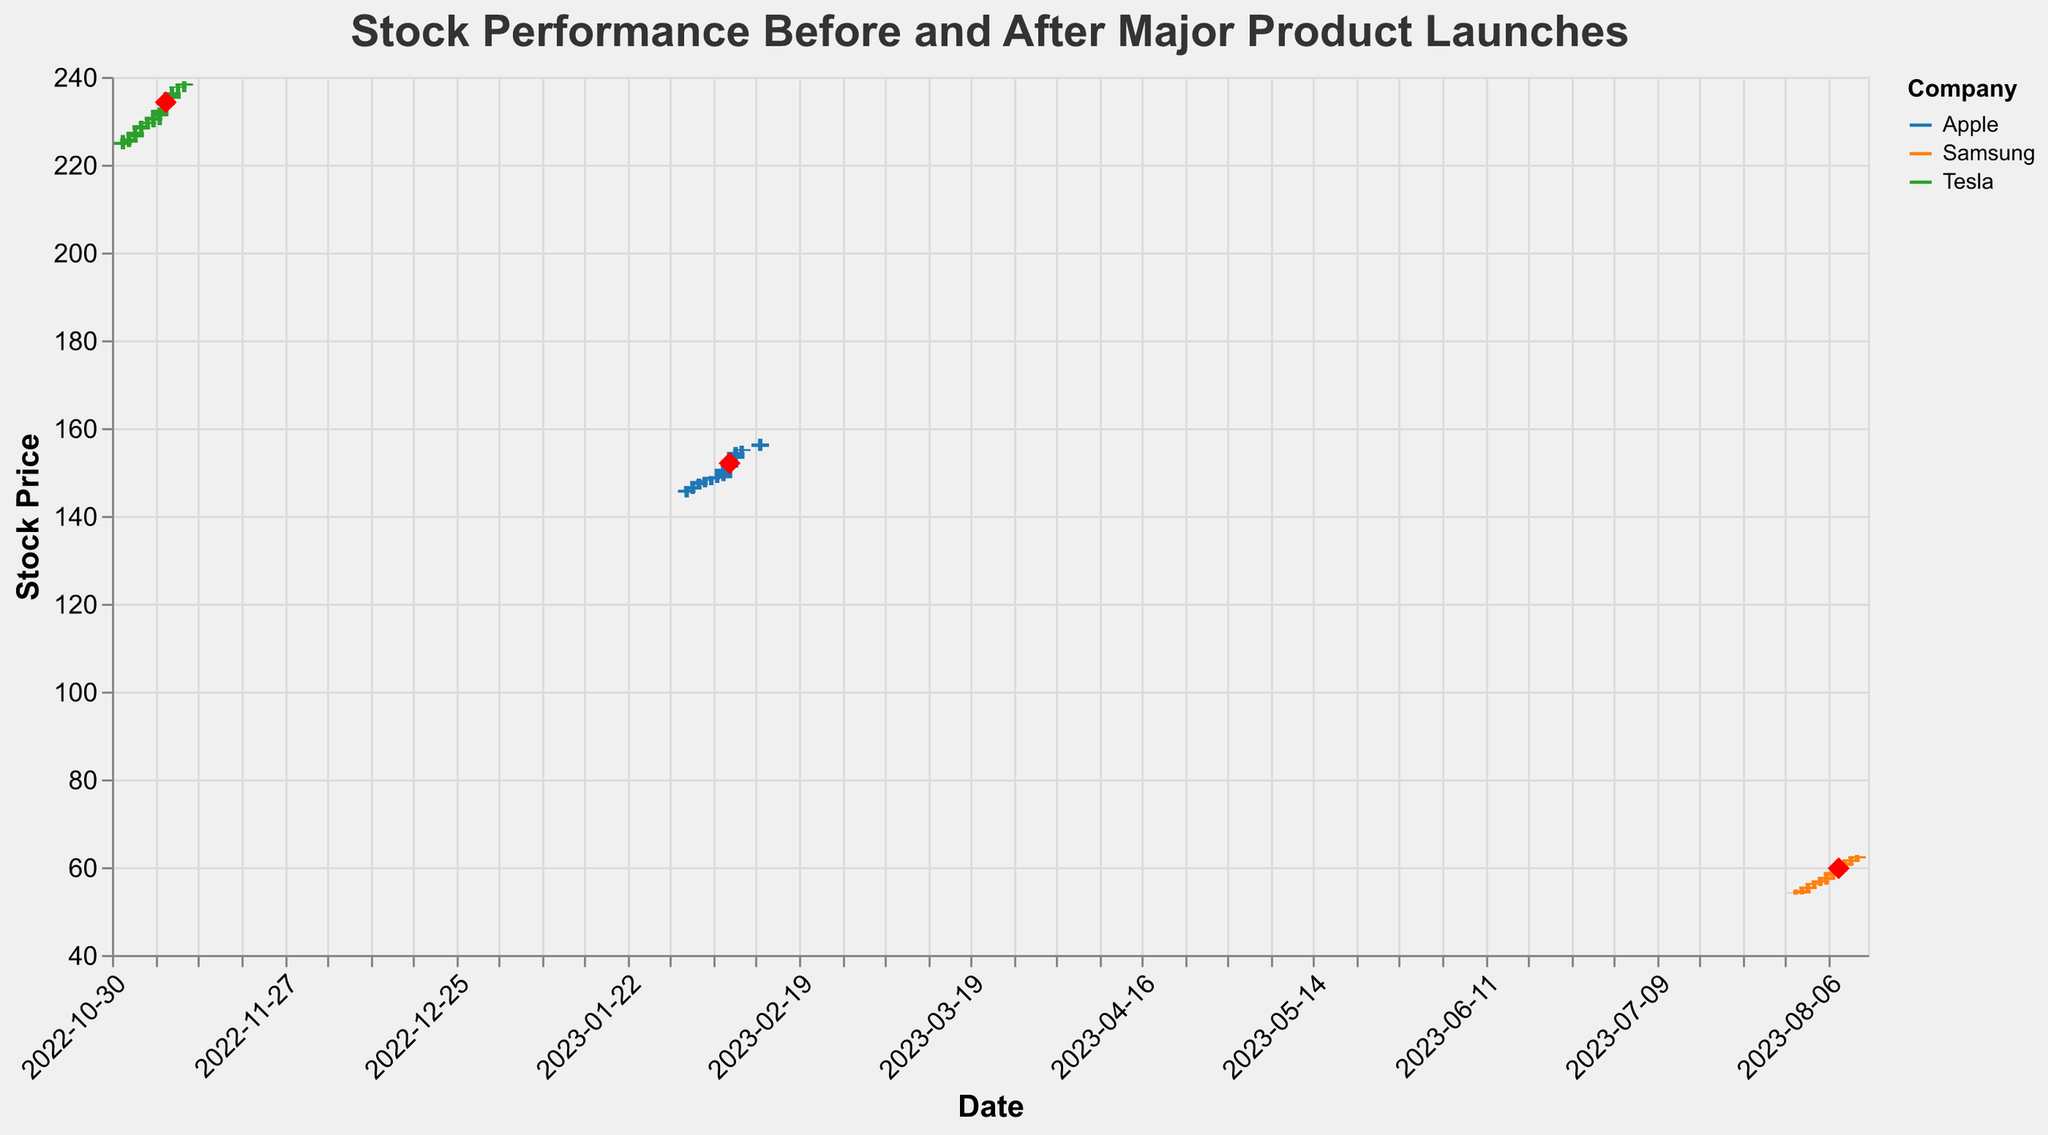How does the stock price of Apple change from the day before the product launch to the day of the product launch? On February 7th, the closing price of Apple is $150.75. On February 8th, which is the product launch day, the closing price rises to $152.00. The difference in closing prices is $152.00 - $150.75 = $1.25, indicating an increase in stock price.
Answer: $1.25 increase Which company saw the highest closing price on the day of its product launch? On February 8th, Apple's closing price is $152.00. On August 8th, Samsung's closing price is $59.75. On November 8th, Tesla's closing price is $234.20. Thus, Tesla has the highest closing price on the day of its product launch.
Answer: Tesla What is the volume of stock traded on the day of Tesla's product launch? On November 8th, the day of Tesla's product launch, the volume of stock traded is 34,000,000.
Answer: 34,000,000 By how much did Samsung's stock price rise on the day after the product launch? On August 8th, Samsung's closing price is $59.75. On August 9th, the closing price rises to $61.00. The price increase is calculated as $61.00 - $59.75 = $1.25.
Answer: $1.25 What is the trend in Apple's stock price in the week leading up to the product launch? Starting from February 1st, the closing prices for Apple are $145.95, $146.80, $147.95, $148.25, $148.90, $148.50, and $150.75 on February 7th. The trend suggests a general increase in closing prices as we approach the product launch.
Answer: Increasing trend Compare the volumes of Apple and Samsung on their respective product launch days. On February 8th, Apple's volume is 95,000,000. On August 8th, Samsung's volume is 85,000,000. Comparing these values: 95,000,000 (Apple) is greater than 85,000,000 (Samsung).
Answer: Apple had higher volume Does Tesla or Samsung have a higher stock price change between the product launch day and the day after? Tesla's closing price on November 8th is $234.20 and on November 9th is $236.50, making the change $236.50 - $234.20 = $2.30. Samsung's closing price on August 8th is $59.75 and on August 9th is $61.00, making the change $61.00 - $59.75 = $1.25. Tesla has a higher stock price change.
Answer: Tesla What was the opening price of Apple on the day of the product launch? On February 8th, Apple's opening price is $151.00.
Answer: $151.00 What is the highest price Tesla reached on the day of its product launch? On November 8th, Tesla's highest price reaches $235.00.
Answer: $235.00 